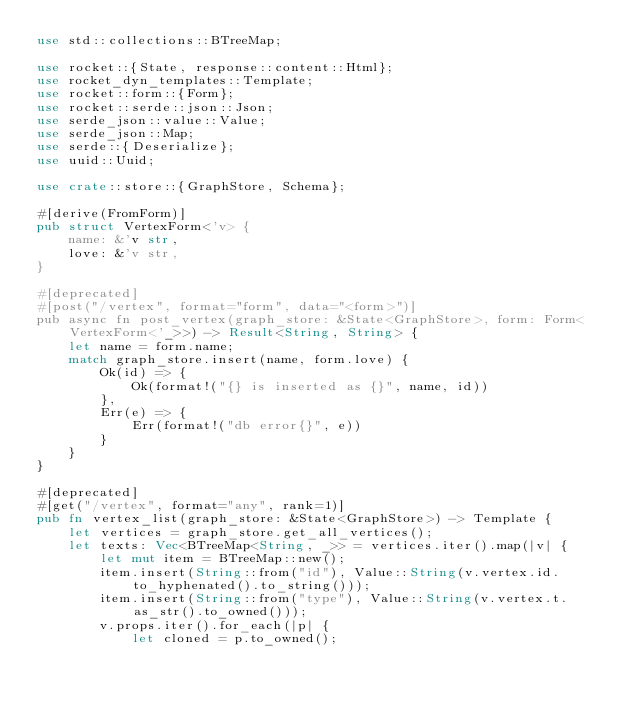Convert code to text. <code><loc_0><loc_0><loc_500><loc_500><_Rust_>use std::collections::BTreeMap;

use rocket::{State, response::content::Html};
use rocket_dyn_templates::Template;
use rocket::form::{Form};
use rocket::serde::json::Json;
use serde_json::value::Value;
use serde_json::Map;
use serde::{Deserialize};
use uuid::Uuid;

use crate::store::{GraphStore, Schema};

#[derive(FromForm)]
pub struct VertexForm<'v> {
    name: &'v str,
    love: &'v str,
}

#[deprecated]
#[post("/vertex", format="form", data="<form>")]
pub async fn post_vertex(graph_store: &State<GraphStore>, form: Form<VertexForm<'_>>) -> Result<String, String> {
    let name = form.name;
    match graph_store.insert(name, form.love) {
        Ok(id) => {
            Ok(format!("{} is inserted as {}", name, id))
        },
        Err(e) => {
            Err(format!("db error{}", e))
        }
    }
}

#[deprecated]
#[get("/vertex", format="any", rank=1)]
pub fn vertex_list(graph_store: &State<GraphStore>) -> Template {
    let vertices = graph_store.get_all_vertices();
    let texts: Vec<BTreeMap<String, _>> = vertices.iter().map(|v| {
        let mut item = BTreeMap::new();
        item.insert(String::from("id"), Value::String(v.vertex.id.to_hyphenated().to_string()));
        item.insert(String::from("type"), Value::String(v.vertex.t.as_str().to_owned()));
        v.props.iter().for_each(|p| {
            let cloned = p.to_owned();</code> 